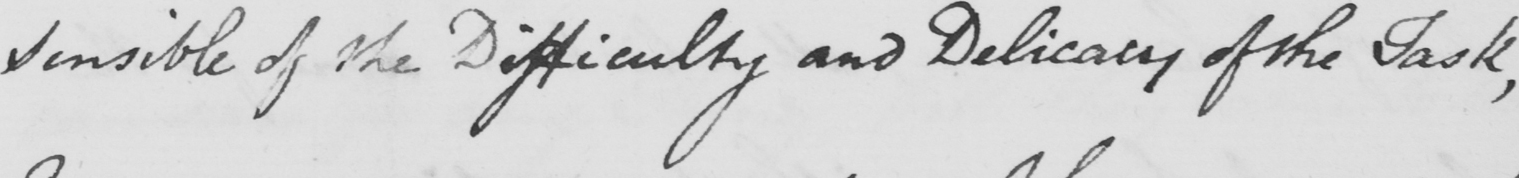Please transcribe the handwritten text in this image. Sensible of the Difficulty and Delicacy of the Task , 